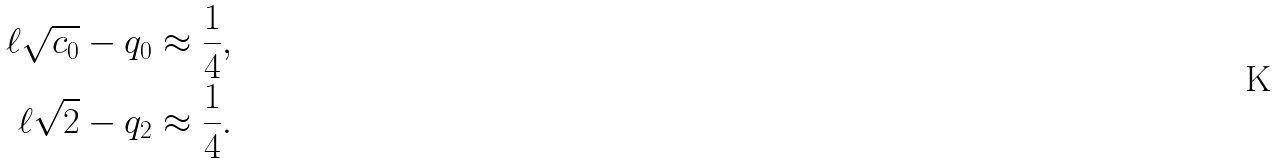<formula> <loc_0><loc_0><loc_500><loc_500>\ell \sqrt { c _ { 0 } } - q _ { 0 } \approx \frac { 1 } { 4 } , \\ \ell \sqrt { 2 } - q _ { 2 } \approx \frac { 1 } { 4 } .</formula> 